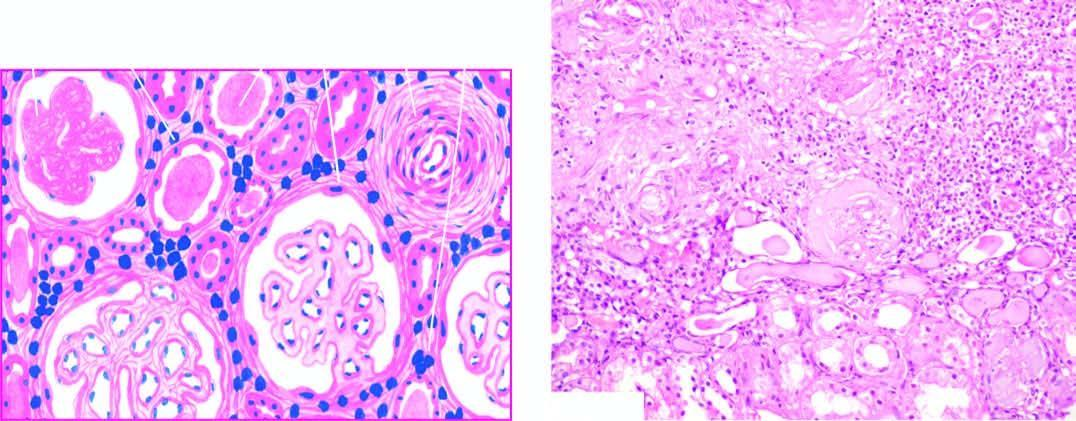re the blood vessels included are thick-walled?
Answer the question using a single word or phrase. Yes 